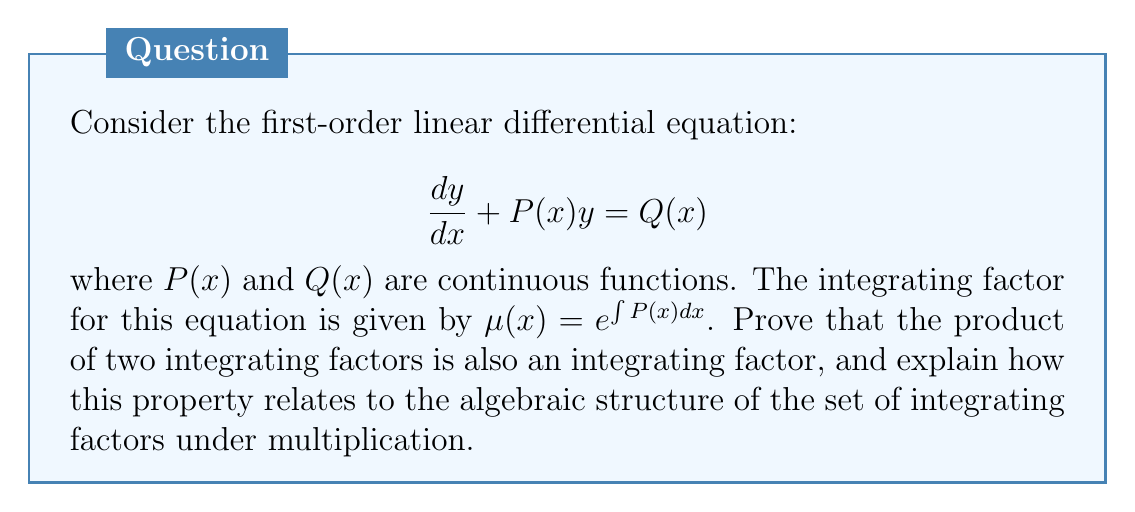Can you solve this math problem? Let's approach this step-by-step:

1) First, let's recall that an integrating factor $\mu(x)$ transforms the given ODE into an exact equation:

   $$\mu(x)\frac{dy}{dx} + \mu(x)P(x)y = \mu(x)Q(x)$$

2) Now, let $\mu_1(x)$ and $\mu_2(x)$ be two integrating factors for the given ODE. We need to prove that their product $\mu_1(x)\mu_2(x)$ is also an integrating factor.

3) Let's apply $\mu_1(x)\mu_2(x)$ to the original ODE:

   $$\mu_1(x)\mu_2(x)\frac{dy}{dx} + \mu_1(x)\mu_2(x)P(x)y = \mu_1(x)\mu_2(x)Q(x)$$

4) For this to be an exact equation, we need:

   $$\frac{d}{dx}[\mu_1(x)\mu_2(x)] = \mu_1(x)\mu_2(x)P(x)$$

5) Let's expand the left-hand side:

   $$\mu_2(x)\frac{d\mu_1(x)}{dx} + \mu_1(x)\frac{d\mu_2(x)}{dx} = \mu_1(x)\mu_2(x)P(x)$$

6) Since $\mu_1(x)$ and $\mu_2(x)$ are integrating factors, we know:

   $$\frac{d\mu_1(x)}{dx} = \mu_1(x)P(x)$$ and $$\frac{d\mu_2(x)}{dx} = \mu_2(x)P(x)$$

7) Substituting these into the equation from step 5:

   $$\mu_2(x)[\mu_1(x)P(x)] + \mu_1(x)[\mu_2(x)P(x)] = \mu_1(x)\mu_2(x)P(x)$$

8) This equality holds, proving that $\mu_1(x)\mu_2(x)$ is indeed an integrating factor.

9) This property relates to the algebraic structure of integrating factors as follows:
   - The set of integrating factors forms a group under multiplication.
   - The identity element is $e^0 = 1$.
   - The inverse of an integrating factor $\mu(x)$ is $\frac{1}{\mu(x)}$.
   - The closure property is demonstrated by our proof.
   - Associativity follows from the associativity of multiplication.

Thus, the set of integrating factors forms an abelian group under multiplication, which is a fundamental algebraic structure.
Answer: The product of integrating factors is an integrating factor; the set of integrating factors forms an abelian group under multiplication. 